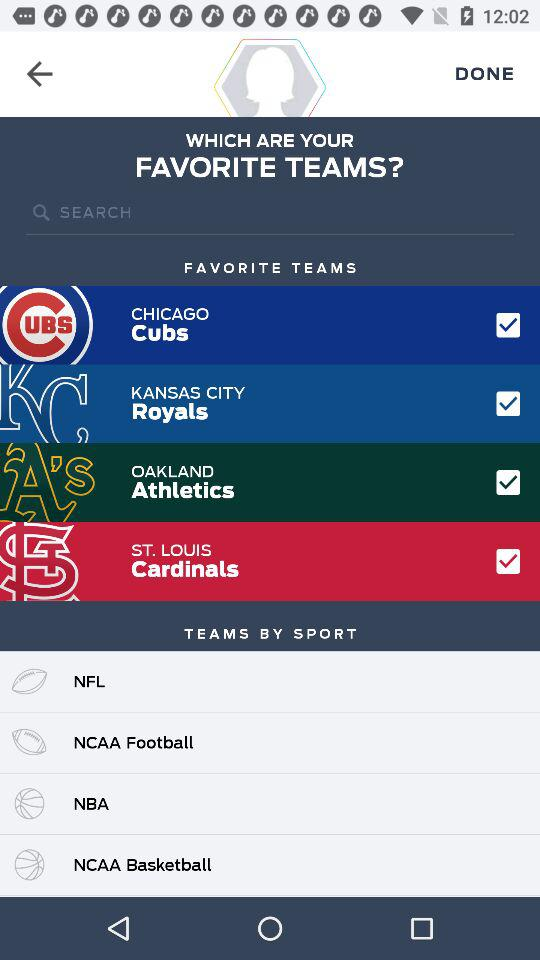How many sports are available to choose from?
Answer the question using a single word or phrase. 4 